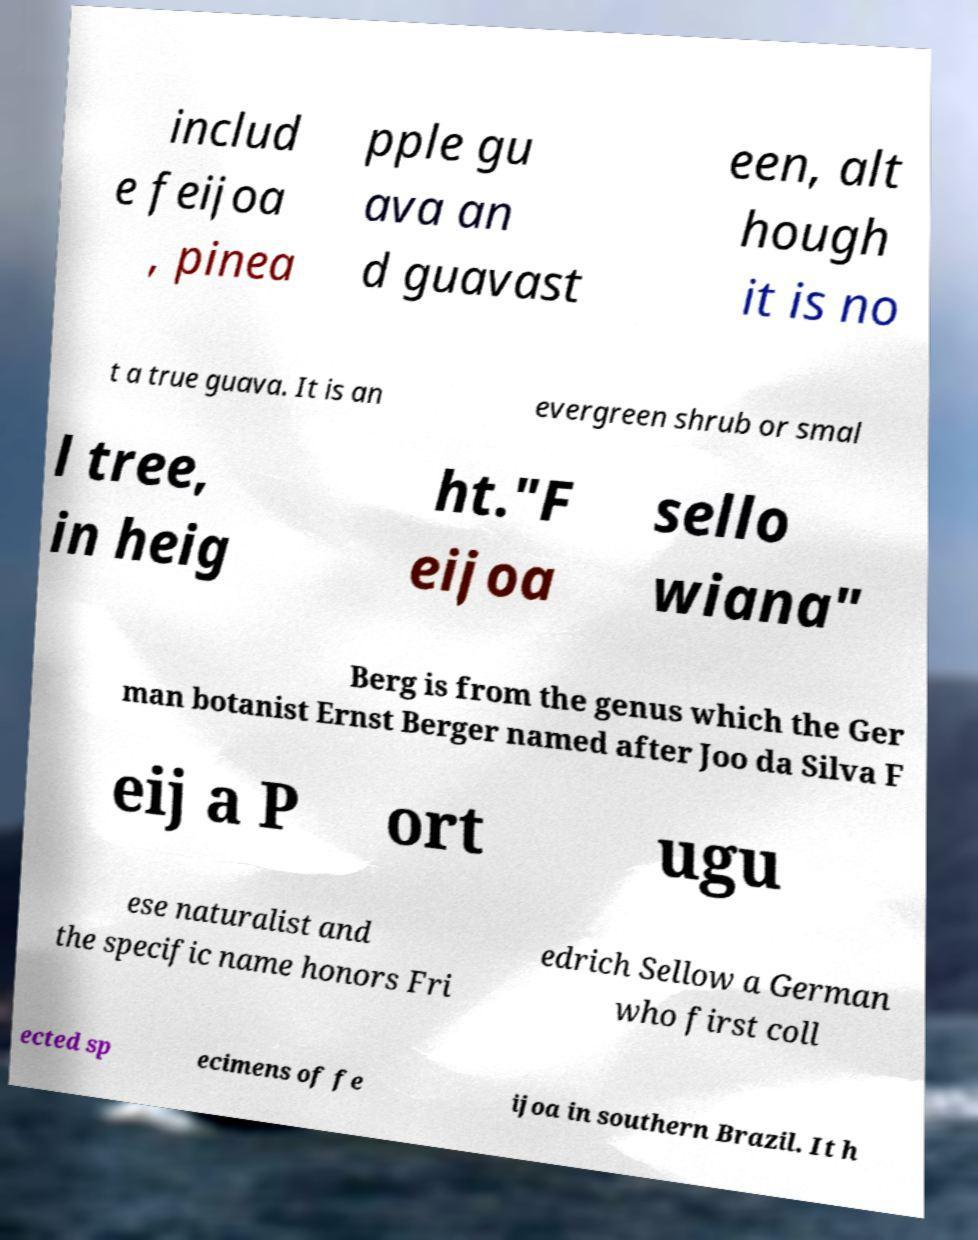What messages or text are displayed in this image? I need them in a readable, typed format. includ e feijoa , pinea pple gu ava an d guavast een, alt hough it is no t a true guava. It is an evergreen shrub or smal l tree, in heig ht."F eijoa sello wiana" Berg is from the genus which the Ger man botanist Ernst Berger named after Joo da Silva F eij a P ort ugu ese naturalist and the specific name honors Fri edrich Sellow a German who first coll ected sp ecimens of fe ijoa in southern Brazil. It h 